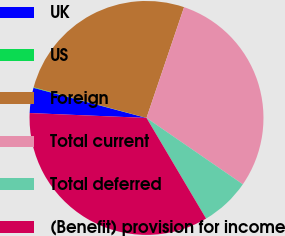Convert chart to OTSL. <chart><loc_0><loc_0><loc_500><loc_500><pie_chart><fcel>UK<fcel>US<fcel>Foreign<fcel>Total current<fcel>Total deferred<fcel>(Benefit) provision for income<nl><fcel>3.48%<fcel>0.07%<fcel>25.99%<fcel>29.4%<fcel>6.89%<fcel>34.17%<nl></chart> 